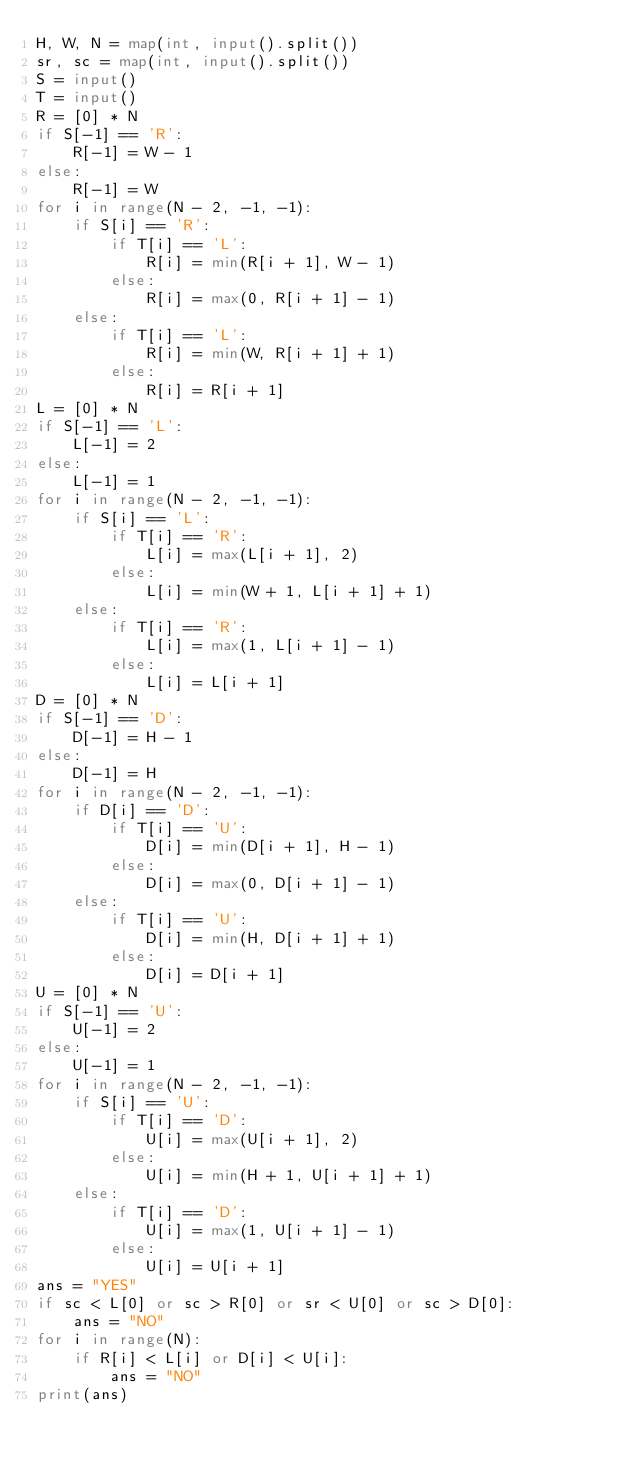<code> <loc_0><loc_0><loc_500><loc_500><_Python_>H, W, N = map(int, input().split())
sr, sc = map(int, input().split())
S = input()
T = input()
R = [0] * N
if S[-1] == 'R':
    R[-1] = W - 1
else:
    R[-1] = W
for i in range(N - 2, -1, -1):
    if S[i] == 'R':
        if T[i] == 'L':
            R[i] = min(R[i + 1], W - 1)
        else:
            R[i] = max(0, R[i + 1] - 1)
    else:
        if T[i] == 'L':
            R[i] = min(W, R[i + 1] + 1)
        else:
            R[i] = R[i + 1]
L = [0] * N
if S[-1] == 'L':
    L[-1] = 2
else:
    L[-1] = 1
for i in range(N - 2, -1, -1):
    if S[i] == 'L':
        if T[i] == 'R':
            L[i] = max(L[i + 1], 2)
        else:
            L[i] = min(W + 1, L[i + 1] + 1)
    else:
        if T[i] == 'R':
            L[i] = max(1, L[i + 1] - 1)
        else:
            L[i] = L[i + 1]
D = [0] * N
if S[-1] == 'D':
    D[-1] = H - 1
else:
    D[-1] = H
for i in range(N - 2, -1, -1):
    if D[i] == 'D':
        if T[i] == 'U':
            D[i] = min(D[i + 1], H - 1)
        else:
            D[i] = max(0, D[i + 1] - 1)
    else:
        if T[i] == 'U':
            D[i] = min(H, D[i + 1] + 1)
        else:
            D[i] = D[i + 1]
U = [0] * N
if S[-1] == 'U':
    U[-1] = 2
else:
    U[-1] = 1
for i in range(N - 2, -1, -1):
    if S[i] == 'U':
        if T[i] == 'D':
            U[i] = max(U[i + 1], 2)
        else:
            U[i] = min(H + 1, U[i + 1] + 1)
    else:
        if T[i] == 'D':
            U[i] = max(1, U[i + 1] - 1)
        else:
            U[i] = U[i + 1]
ans = "YES"
if sc < L[0] or sc > R[0] or sr < U[0] or sc > D[0]:
    ans = "NO"
for i in range(N):
    if R[i] < L[i] or D[i] < U[i]:
        ans = "NO"
print(ans)</code> 